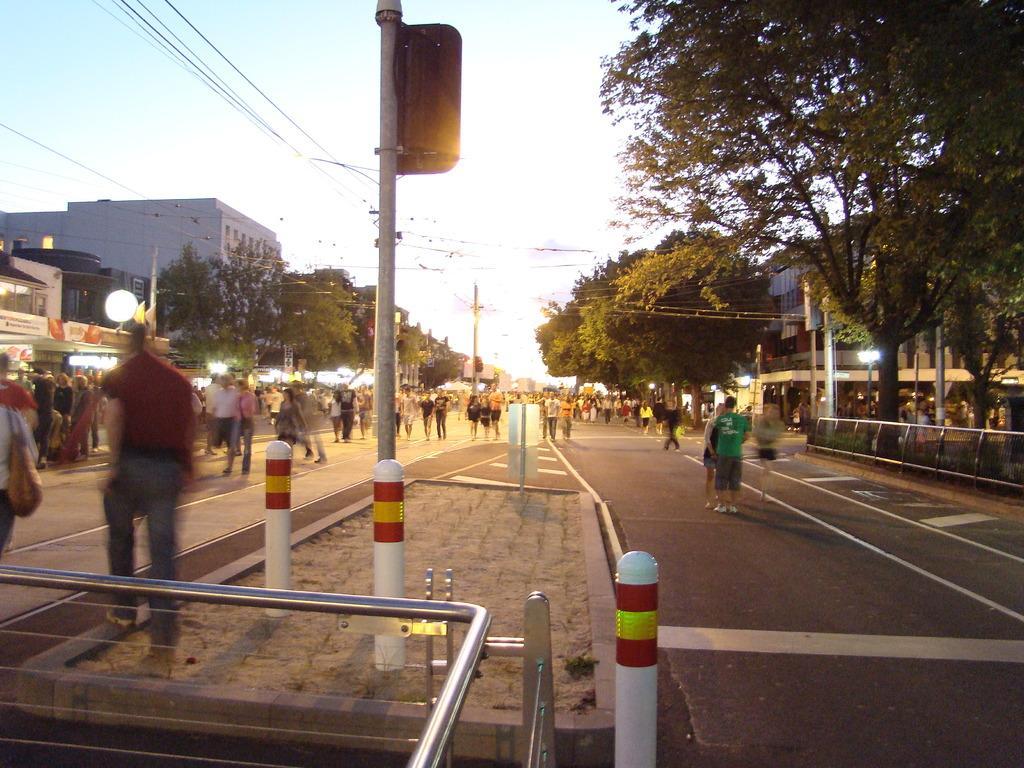Describe this image in one or two sentences. On the road there are a lot of people walking beside the footpath,beside the people there are some stores and buildings and plenty of trees and in between the road there are some poles and there are a lot of wires attached to the poles. 